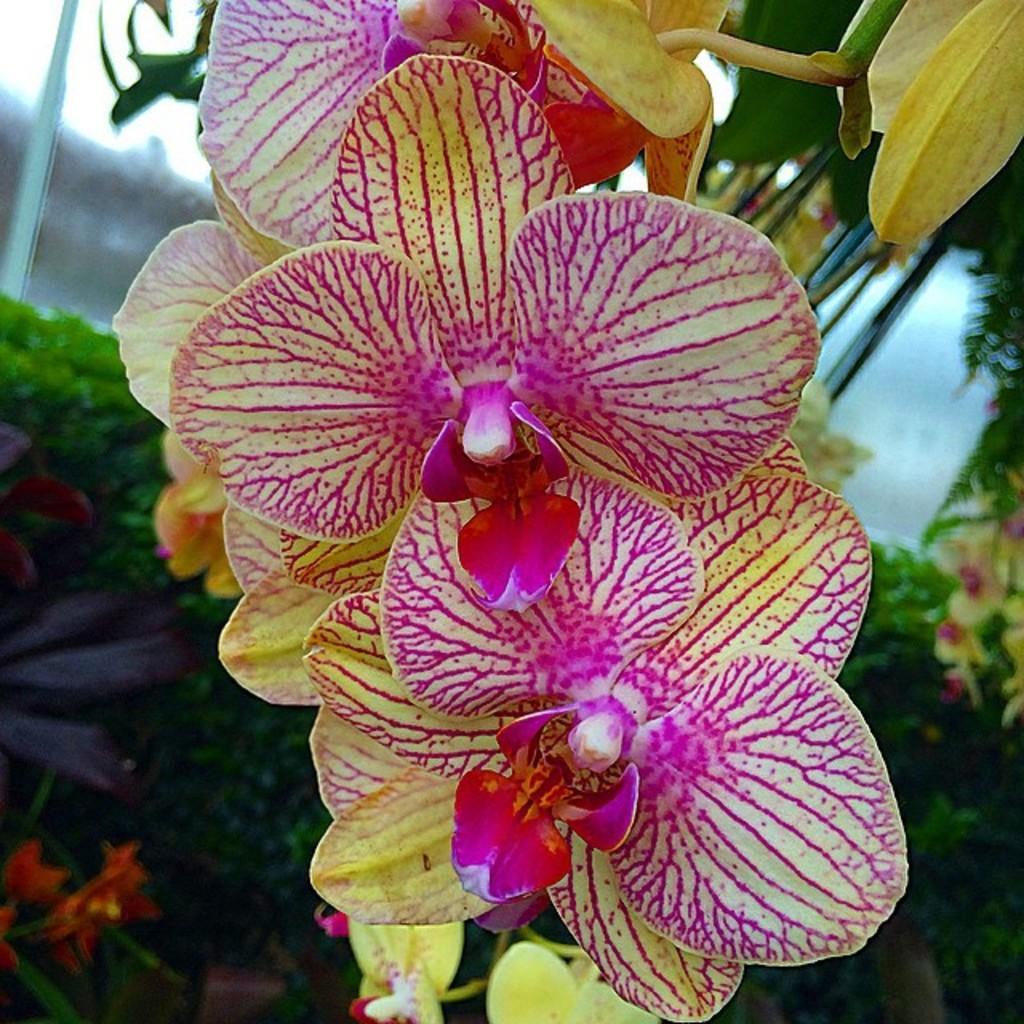Describe this image in one or two sentences. In this image, I can see the flowers, which are pink and yellow in color. In the background, I can see the plants and bushes. 